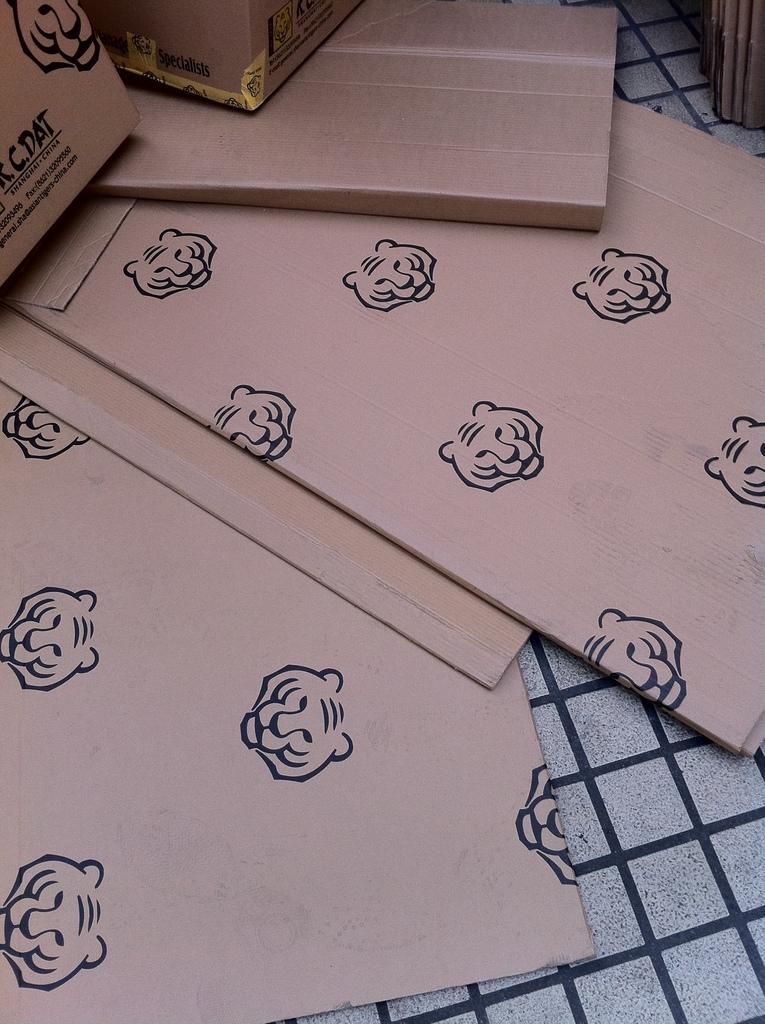What type of objects are on the floor in the image? There are cardboard boxes on the floor in the image. What is depicted on the cardboard boxes? The cardboard boxes have symbols of a tiger face on them. How much does the bat weigh in the image? There is no bat present in the image, so it is not possible to determine its weight. 